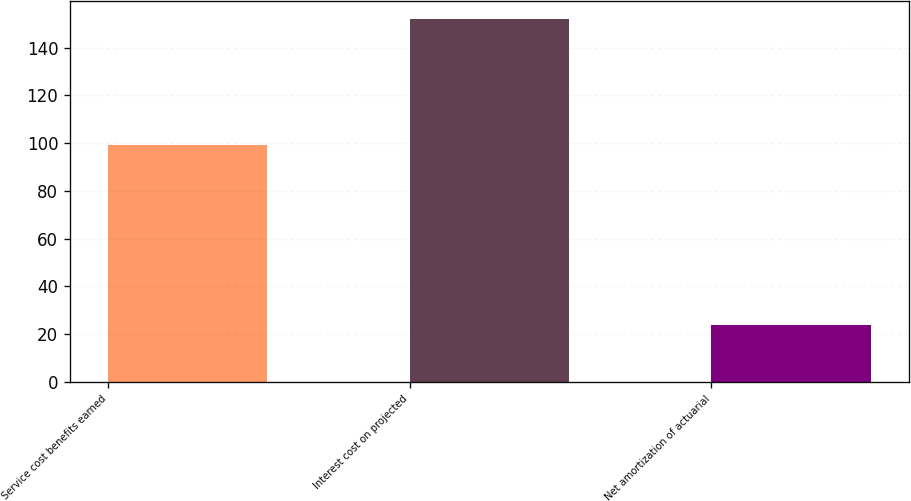<chart> <loc_0><loc_0><loc_500><loc_500><bar_chart><fcel>Service cost benefits earned<fcel>Interest cost on projected<fcel>Net amortization of actuarial<nl><fcel>99<fcel>152<fcel>24<nl></chart> 